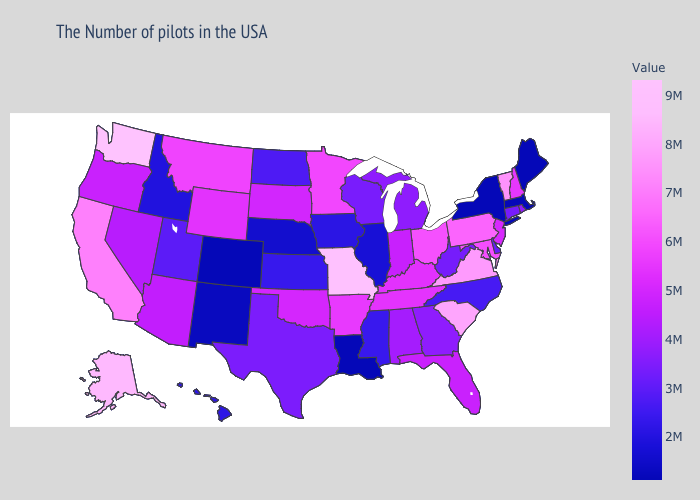Does California have a lower value than Tennessee?
Quick response, please. No. Among the states that border Utah , does Arizona have the lowest value?
Answer briefly. No. Among the states that border Kansas , does Missouri have the highest value?
Write a very short answer. Yes. 